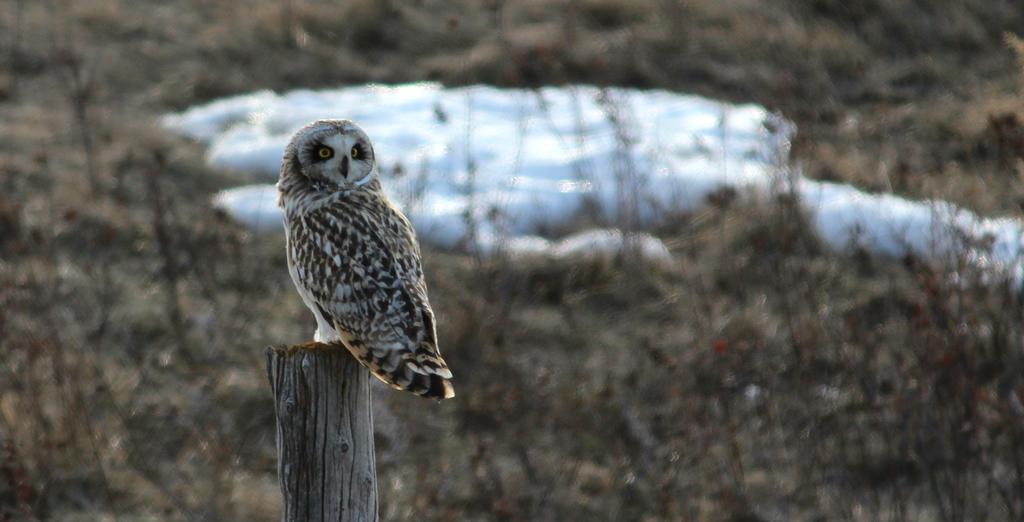Please provide a concise description of this image. This image consists of a owl sitting on a wooden block. In the background, we can see the plants. In the middle, it looks like a snow. 